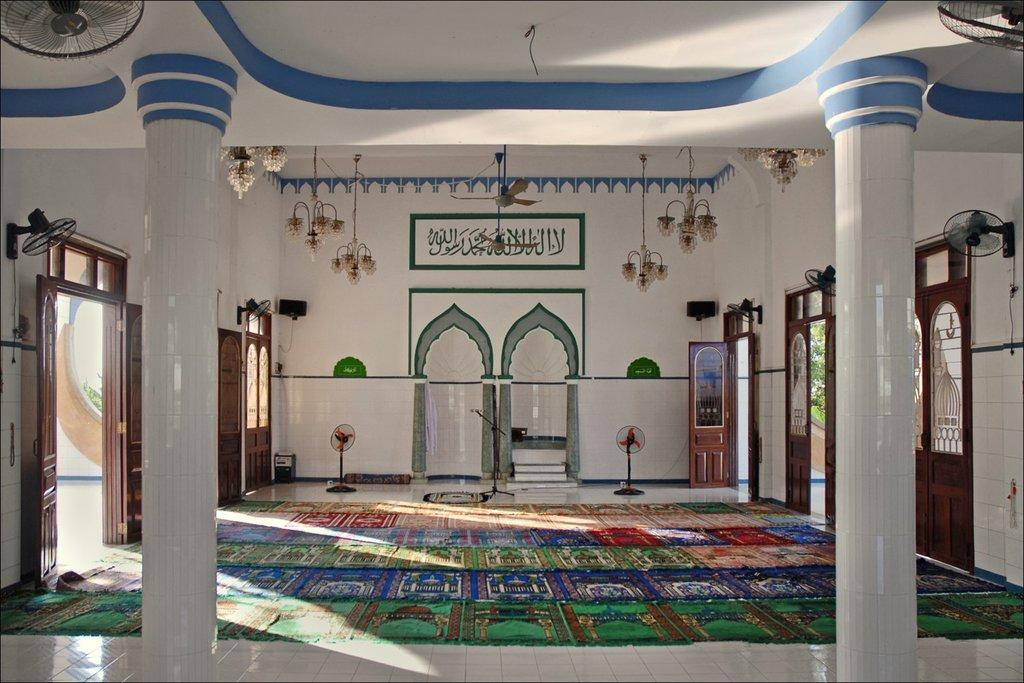What can be found on the left and right sides of the image? There are doors on the left and right sides of the image. What appliances are visible in the image? There are fans in the image. What is hanging at the top of the image? Lights are hanging at the top of the image. Can you see a robin perched on the fan in the image? There is no robin present in the image; it only features doors, fans, and lights. What type of cap is being worn by the person in the image? There is no person present in the image, so it is impossible to determine if anyone is wearing a cap. 